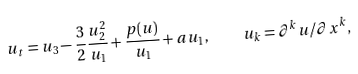Convert formula to latex. <formula><loc_0><loc_0><loc_500><loc_500>u _ { t } = u _ { 3 } - \frac { 3 } { 2 } \frac { u _ { 2 } ^ { 2 } } { u _ { 1 } } + \frac { p ( u ) } { u _ { 1 } } + a u _ { 1 } , \quad u _ { k } = \partial ^ { k } u / \partial x ^ { k } ,</formula> 